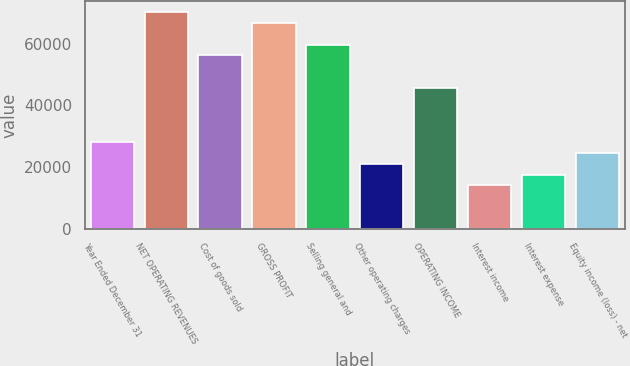Convert chart to OTSL. <chart><loc_0><loc_0><loc_500><loc_500><bar_chart><fcel>Year Ended December 31<fcel>NET OPERATING REVENUES<fcel>Cost of goods sold<fcel>GROSS PROFIT<fcel>Selling general and<fcel>Other operating charges<fcel>OPERATING INCOME<fcel>Interest income<fcel>Interest expense<fcel>Equity income (loss) - net<nl><fcel>28096.2<fcel>70232.9<fcel>56187.3<fcel>66721.5<fcel>59698.7<fcel>21073.4<fcel>45653.1<fcel>14050.6<fcel>17562<fcel>24584.8<nl></chart> 